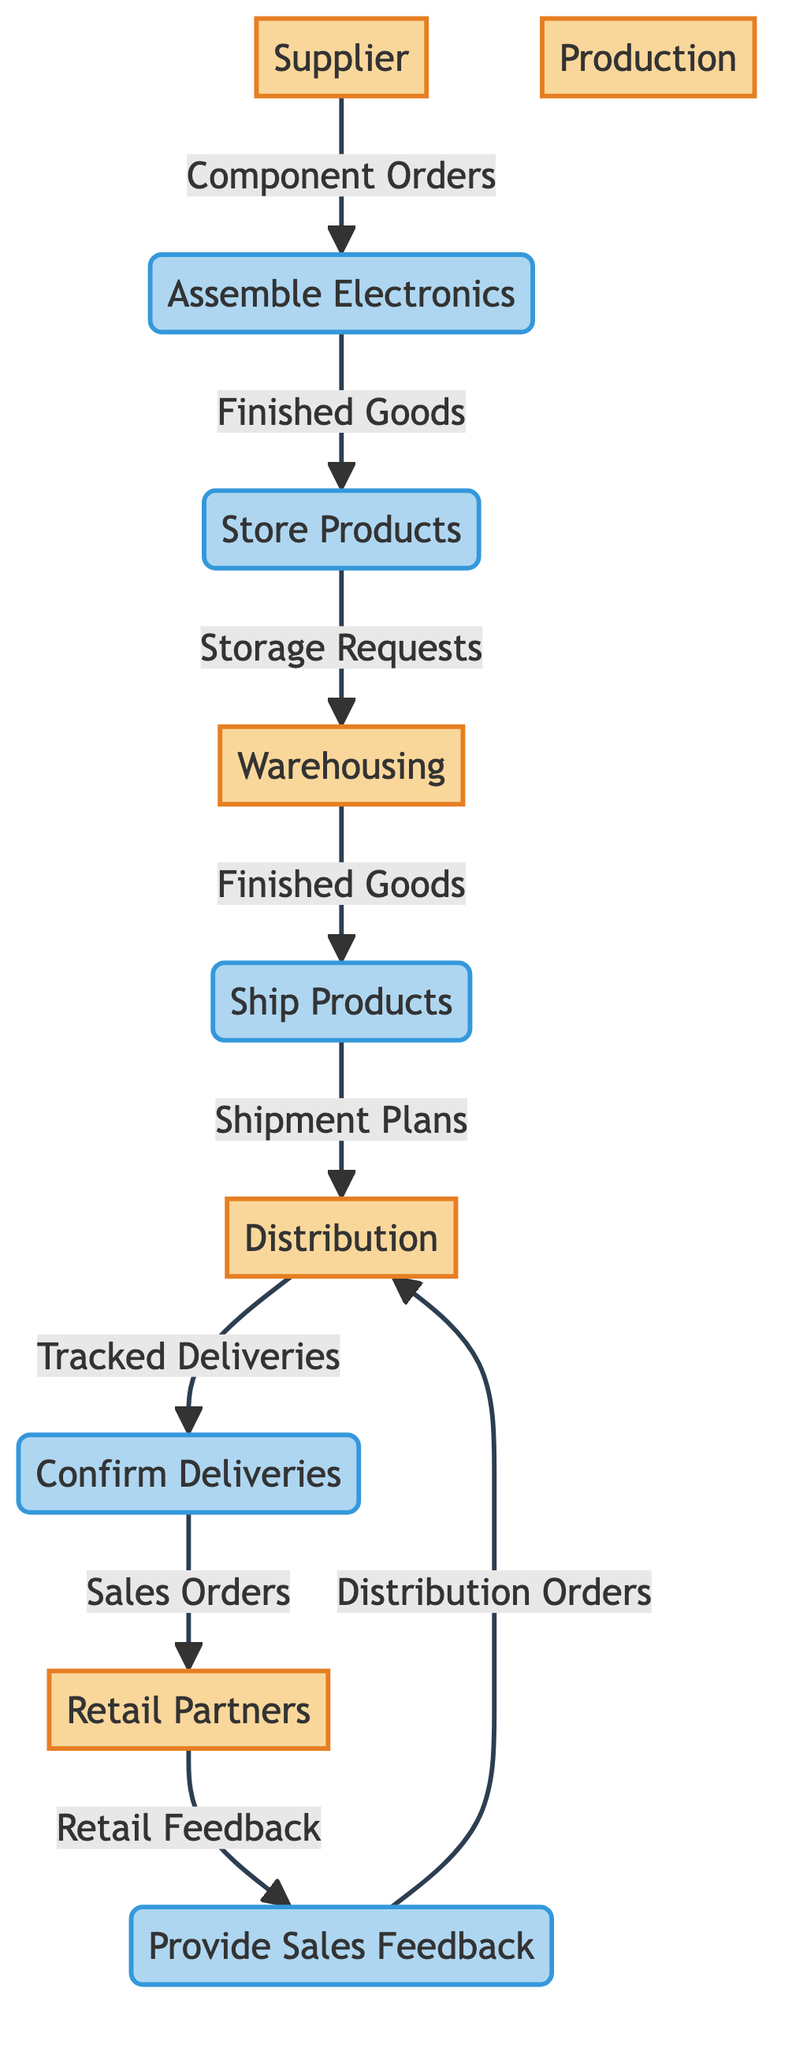What is the first step in the data flow from Supplier? The first step involves sending "Component Orders" from the Supplier to the Production process. This is the initial data transfer that kicks off the assembly process.
Answer: Component Orders How many processes are shown in the diagram? The diagram illustrates five distinct processes involved in data flow: Assemble Electronics, Store Products, Ship Products, Confirm Deliveries, and Provide Sales Feedback.
Answer: Five Which entity receives Finished Goods directly from Production? The Warehousing entity is responsible for receiving Finished Goods from the Production process, indicating the transition of products from assembly to storage.
Answer: Warehousing What data flows from Retail Partners back to Distribution? Retail Feedback is the data that flows from Retail Partners back to the Distribution entity, showing the communication loop between retail and distribution.
Answer: Retail Feedback In which process is Finished Goods utilized as input? "Store Products" is the process where Finished Goods are utilized as input, emphasizing the importance of finished products in inventory management.
Answer: Store Products What is the last data flow in the diagram? The last data flow in the diagram is from Retail Partners to Distribution, represented by the flow of Retail Feedback that informs distribution decisions.
Answer: Retail Feedback How many unique entities are present in the diagram? There are five unique entities depicted in the diagram: Supplier, Production, Warehousing, Distribution, and Retail Partners, detailing the supply chain.
Answer: Five What is the output of the process "Confirm Deliveries"? The output of the Confirm Deliveries process is Sales Orders, demonstrating the confirmation of transactions with retail partners.
Answer: Sales Orders Which process follows the Store Products in the data flow? The process that follows Store Products is Ship Products, indicating the sequence from storing items to preparing them for shipment.
Answer: Ship Products What are the two inputs required for the Assembly Electronics process? The two inputs needed for the Assemble Electronics process are Component Orders and Bill of Materials, which are essential for the assembly of electronics.
Answer: Component Orders, Bill of Materials 